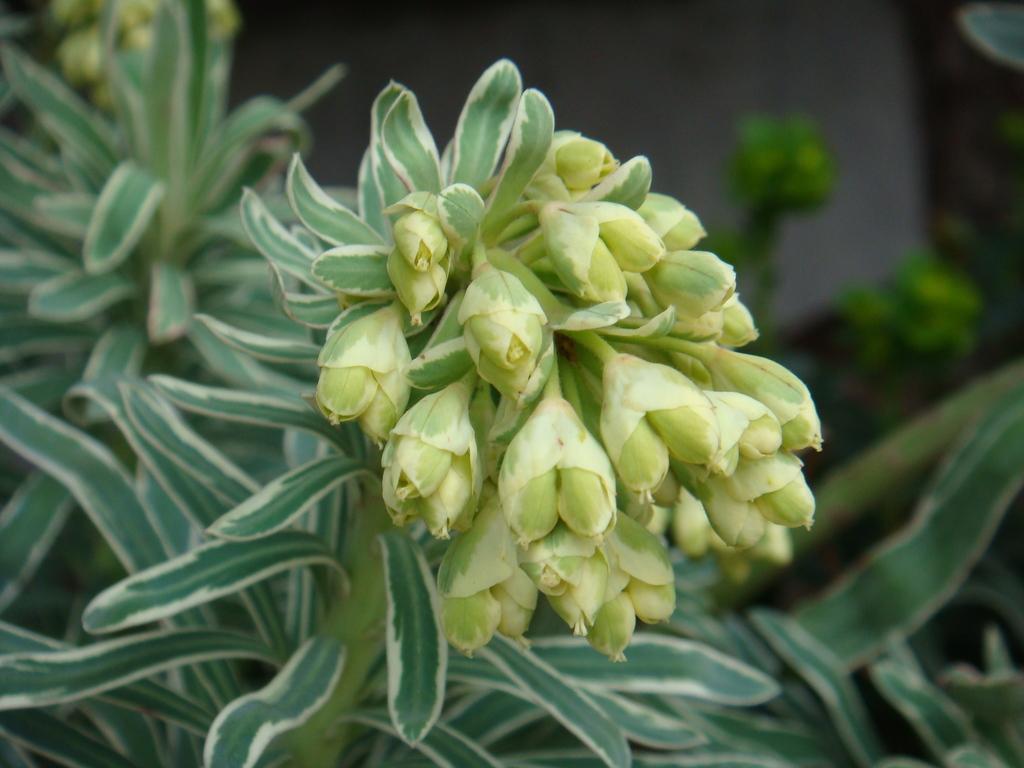Can you describe this image briefly? In this picture we can see buds, leaves and stems. In the background of the image it is blurry. 